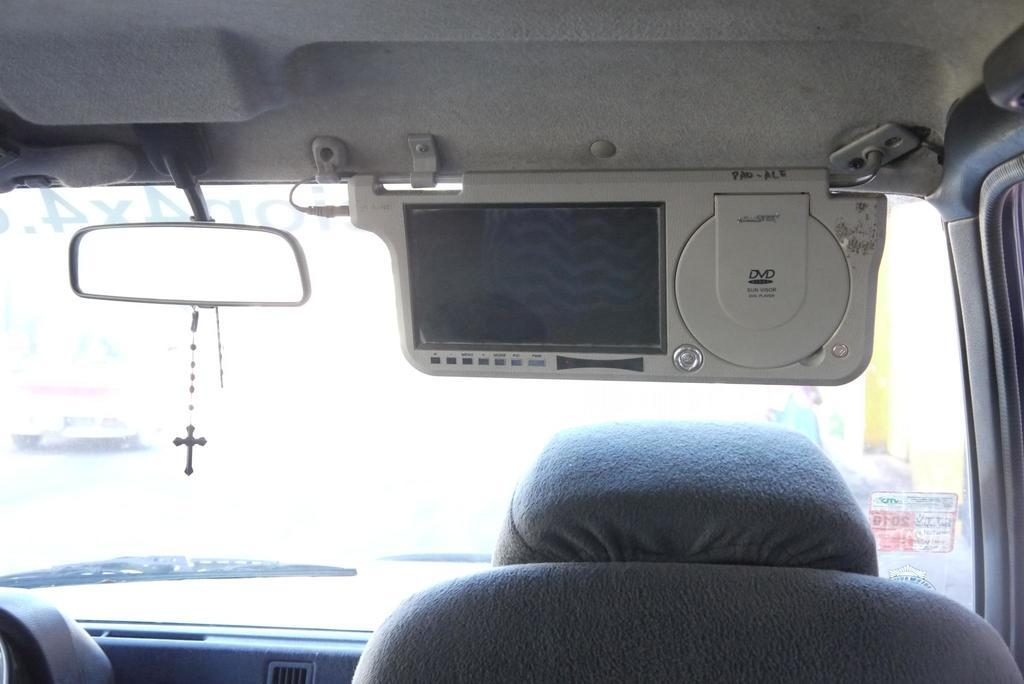What object in the image allows for reflection? There is a mirror in the image. What object in the image is used for displaying visual content? There is a screen in the image. What object in the image provides a place to sit? There is a seat in the image. What color is the background of the image? The background of the image is white. What type of base is required for the stranger to stand on in the image? There is no stranger present in the image, so no base is required for them to stand on. 